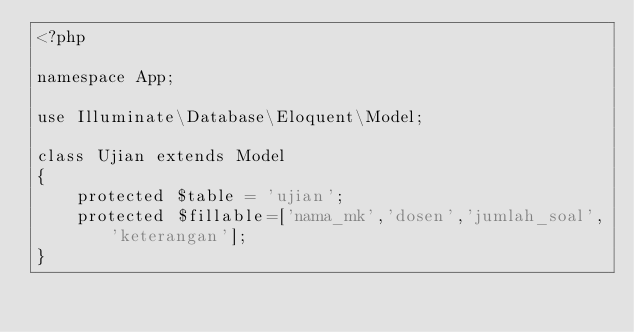<code> <loc_0><loc_0><loc_500><loc_500><_PHP_><?php

namespace App;

use Illuminate\Database\Eloquent\Model;

class Ujian extends Model
{
    protected $table = 'ujian';
    protected $fillable=['nama_mk','dosen','jumlah_soal','keterangan'];
}
</code> 